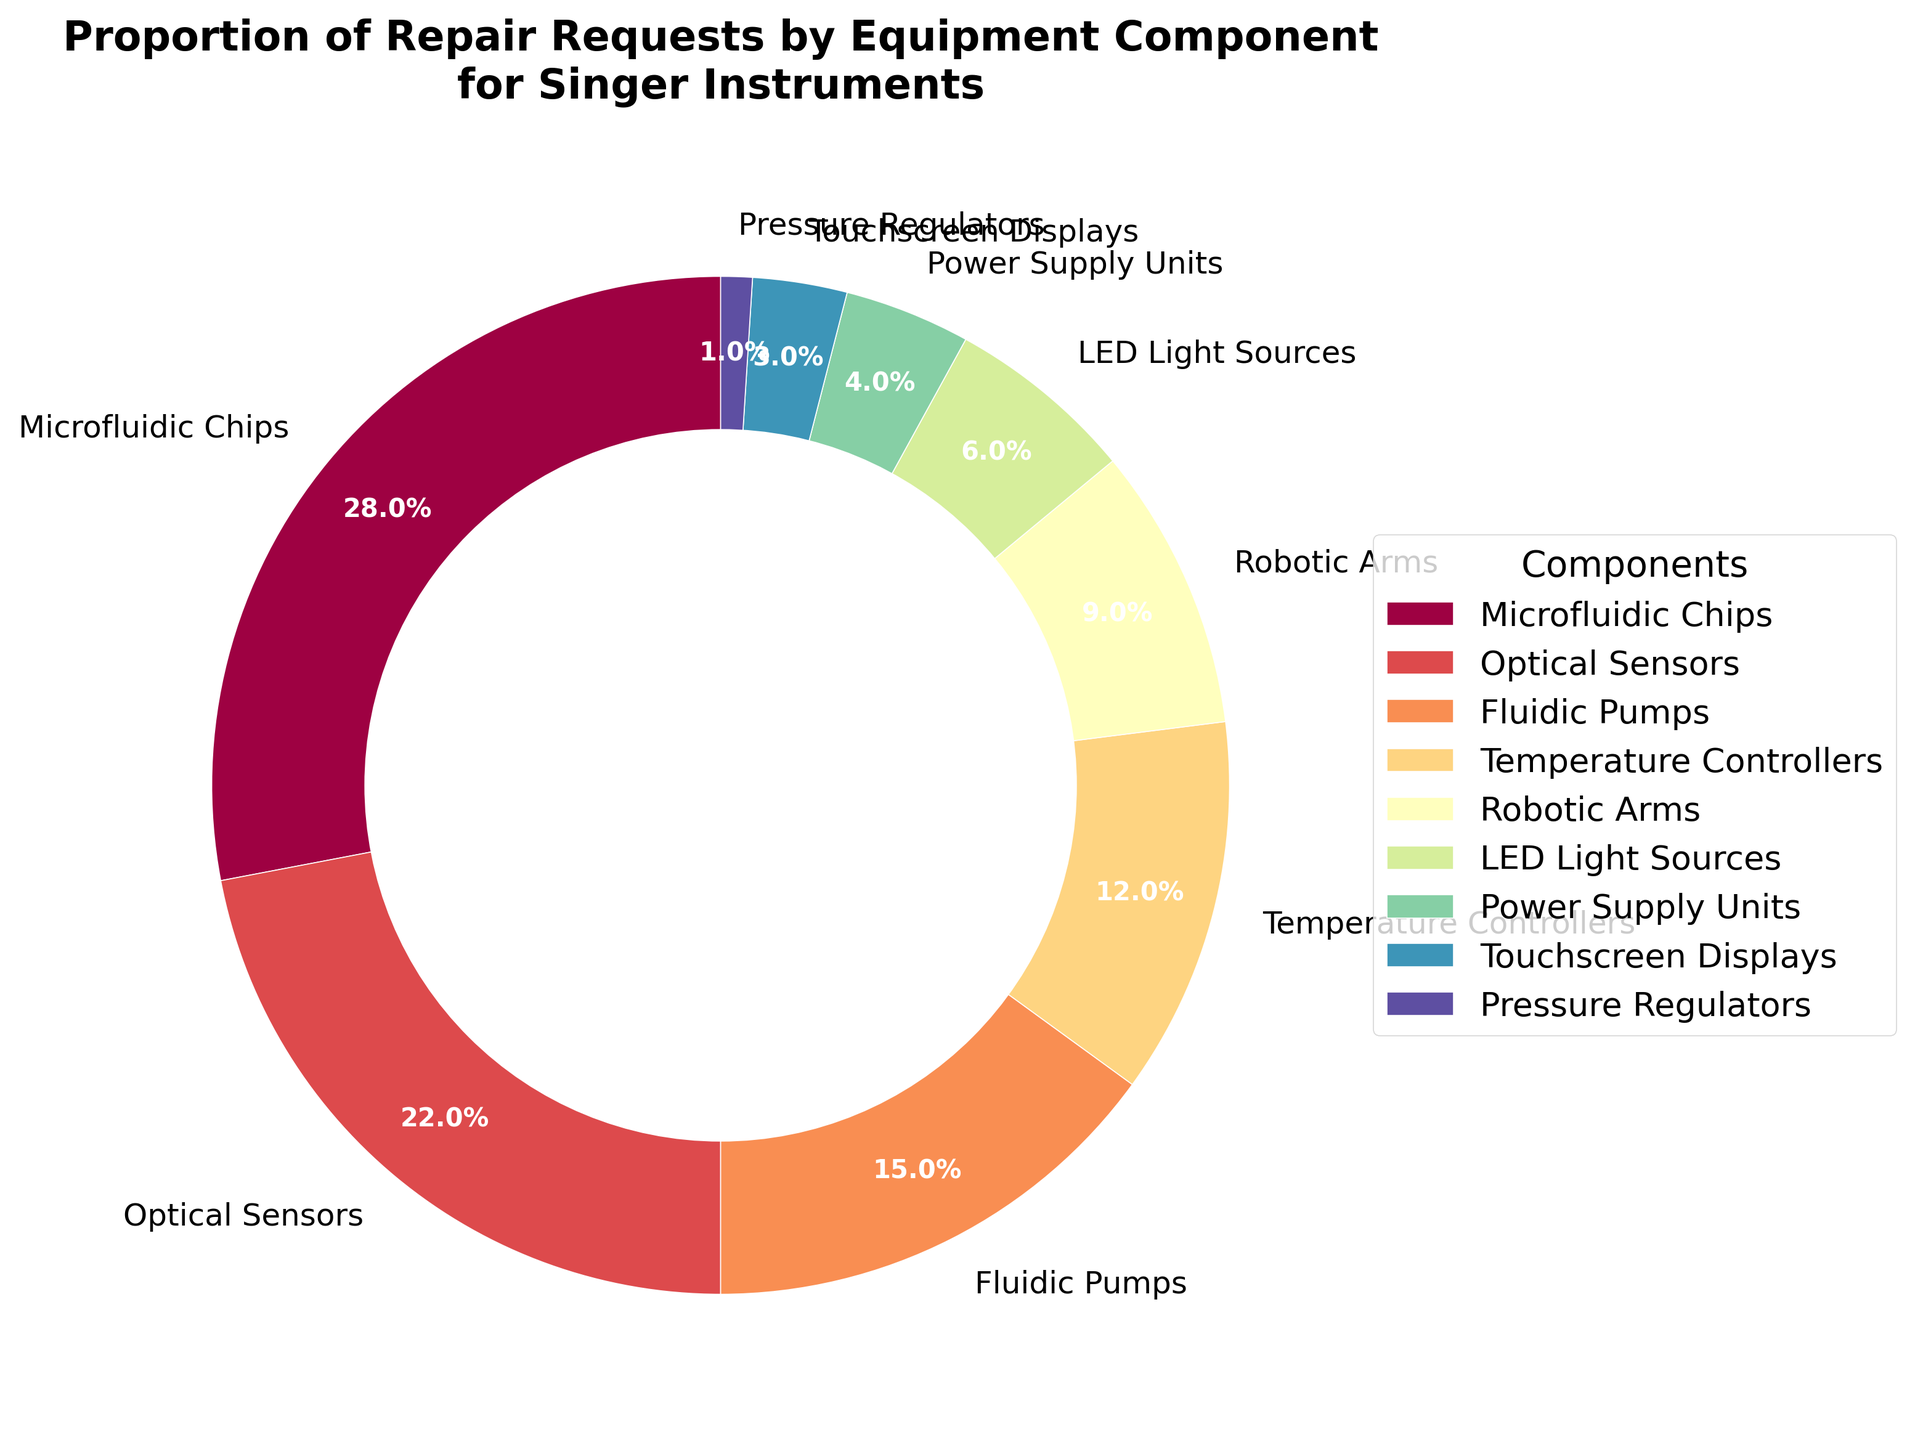Which component has the highest proportion of repair requests? From the pie chart, the largest wedge should represent the component with the highest proportion. The label and percentage on the slice indicate "Microfluidic Chips" with 28%.
Answer: Microfluidic Chips Which component has the lowest proportion of repair requests? Examining the smallest wedge in the pie chart, the smallest percentage listed is 1% labeled as "Pressure Regulators".
Answer: Pressure Regulators What is the combined percentage of repair requests for Fluidic Pumps and Temperature Controllers? Add the percentage values from the pie chart for Fluidic Pumps (15%) and Temperature Controllers (12%). The sum is 15% + 12% = 27%.
Answer: 27% How does the proportion of repair requests for Optical Sensors compare with Robotic Arms? By comparing the wedges in the pie chart, Optical Sensors have a larger percentage (22%) than Robotic Arms (9%).
Answer: Optical Sensors have a higher proportion What is the difference in repair request proportions between the LED Light Sources and Power Supply Units? Subtract the percentage of Power Supply Units (4%) from LED Light Sources (6%) using information from the pie chart. 6% - 4% = 2%.
Answer: 2% Are there more repair requests for Temperature Controllers than for Fluidic Pumps? Comparing the percentages from the pie chart shows that Fluidic Pumps (15%) have a higher value than Temperature Controllers (12%).
Answer: No What percentage of repair requests is for components other than Microfluidic Chips? Subtract the percentage for Microfluidic Chips (28%) from 100%. 100% - 28% = 72%.
Answer: 72% Which color represents Touchscreen Displays in the pie chart? Locate the slice labeled "Touchscreen Displays" in the pie chart and note its color.
Answer: Varies depending on the color palette; check the color on the pie chart directly How many components have a repair request proportion greater than 10%? Identify and count the wedges with values above 10% on the pie chart: Microfluidic Chips (28%), Optical Sensors (22%), Fluidic Pumps (15%), Temperature Controllers (12%). There are 4 such components.
Answer: 4 What is the total percentage of repair requests for Robotic Arms, LED Light Sources, and Power Supply Units combined? Add the percentages for Robotic Arms (9%), LED Light Sources (6%), and Power Supply Units (4%). The sum is 9% + 6% + 4% = 19%.
Answer: 19% 